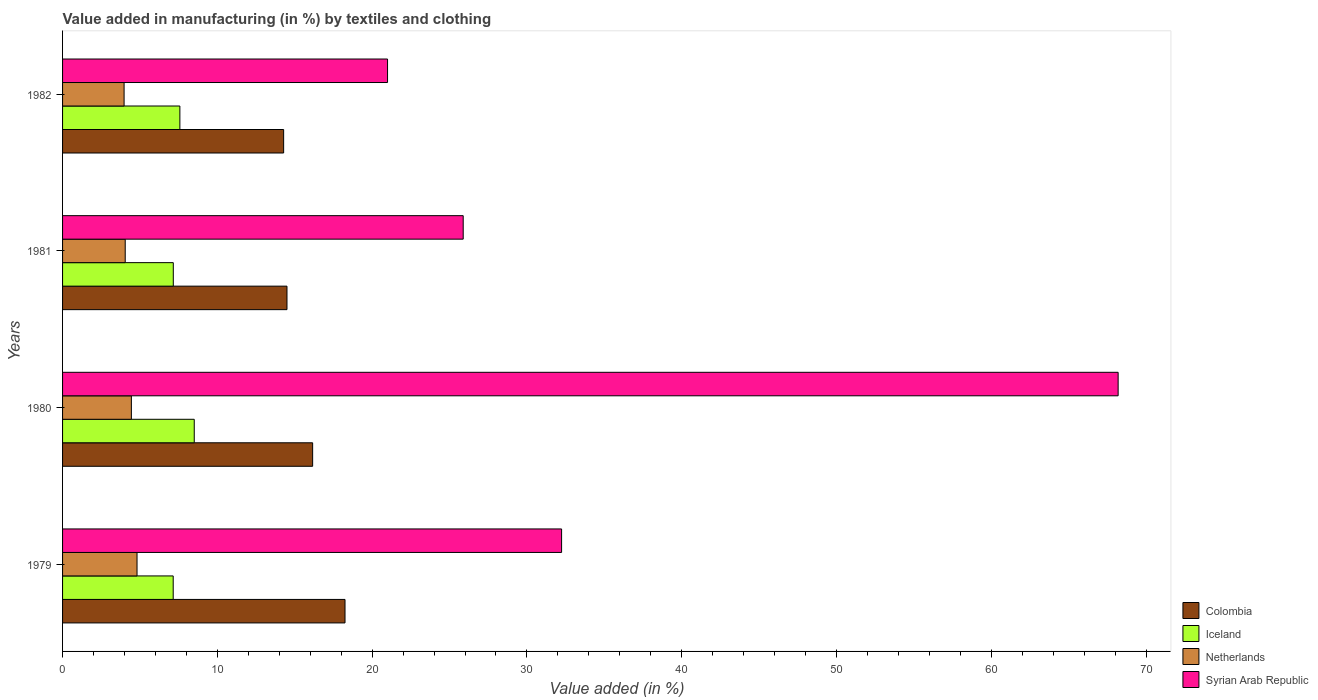How many groups of bars are there?
Give a very brief answer. 4. Are the number of bars per tick equal to the number of legend labels?
Keep it short and to the point. Yes. How many bars are there on the 3rd tick from the top?
Give a very brief answer. 4. What is the label of the 3rd group of bars from the top?
Give a very brief answer. 1980. In how many cases, is the number of bars for a given year not equal to the number of legend labels?
Offer a very short reply. 0. What is the percentage of value added in manufacturing by textiles and clothing in Netherlands in 1979?
Ensure brevity in your answer.  4.81. Across all years, what is the maximum percentage of value added in manufacturing by textiles and clothing in Iceland?
Provide a short and direct response. 8.51. Across all years, what is the minimum percentage of value added in manufacturing by textiles and clothing in Iceland?
Keep it short and to the point. 7.15. In which year was the percentage of value added in manufacturing by textiles and clothing in Netherlands maximum?
Your response must be concise. 1979. In which year was the percentage of value added in manufacturing by textiles and clothing in Netherlands minimum?
Provide a succinct answer. 1982. What is the total percentage of value added in manufacturing by textiles and clothing in Syrian Arab Republic in the graph?
Your response must be concise. 147.32. What is the difference between the percentage of value added in manufacturing by textiles and clothing in Colombia in 1979 and that in 1980?
Your answer should be compact. 2.09. What is the difference between the percentage of value added in manufacturing by textiles and clothing in Colombia in 1981 and the percentage of value added in manufacturing by textiles and clothing in Syrian Arab Republic in 1980?
Keep it short and to the point. -53.7. What is the average percentage of value added in manufacturing by textiles and clothing in Iceland per year?
Provide a short and direct response. 7.6. In the year 1981, what is the difference between the percentage of value added in manufacturing by textiles and clothing in Netherlands and percentage of value added in manufacturing by textiles and clothing in Syrian Arab Republic?
Provide a succinct answer. -21.84. In how many years, is the percentage of value added in manufacturing by textiles and clothing in Netherlands greater than 24 %?
Offer a very short reply. 0. What is the ratio of the percentage of value added in manufacturing by textiles and clothing in Netherlands in 1979 to that in 1982?
Offer a very short reply. 1.21. Is the percentage of value added in manufacturing by textiles and clothing in Netherlands in 1979 less than that in 1982?
Keep it short and to the point. No. Is the difference between the percentage of value added in manufacturing by textiles and clothing in Netherlands in 1979 and 1982 greater than the difference between the percentage of value added in manufacturing by textiles and clothing in Syrian Arab Republic in 1979 and 1982?
Your answer should be very brief. No. What is the difference between the highest and the second highest percentage of value added in manufacturing by textiles and clothing in Syrian Arab Republic?
Your answer should be very brief. 35.96. What is the difference between the highest and the lowest percentage of value added in manufacturing by textiles and clothing in Netherlands?
Ensure brevity in your answer.  0.84. What does the 3rd bar from the bottom in 1979 represents?
Offer a terse response. Netherlands. Is it the case that in every year, the sum of the percentage of value added in manufacturing by textiles and clothing in Colombia and percentage of value added in manufacturing by textiles and clothing in Netherlands is greater than the percentage of value added in manufacturing by textiles and clothing in Iceland?
Give a very brief answer. Yes. How many bars are there?
Your response must be concise. 16. How many years are there in the graph?
Provide a succinct answer. 4. What is the difference between two consecutive major ticks on the X-axis?
Provide a short and direct response. 10. Does the graph contain any zero values?
Give a very brief answer. No. How many legend labels are there?
Keep it short and to the point. 4. How are the legend labels stacked?
Give a very brief answer. Vertical. What is the title of the graph?
Offer a very short reply. Value added in manufacturing (in %) by textiles and clothing. Does "Morocco" appear as one of the legend labels in the graph?
Your response must be concise. No. What is the label or title of the X-axis?
Provide a succinct answer. Value added (in %). What is the Value added (in %) in Colombia in 1979?
Make the answer very short. 18.25. What is the Value added (in %) in Iceland in 1979?
Keep it short and to the point. 7.15. What is the Value added (in %) in Netherlands in 1979?
Provide a short and direct response. 4.81. What is the Value added (in %) of Syrian Arab Republic in 1979?
Keep it short and to the point. 32.24. What is the Value added (in %) in Colombia in 1980?
Your response must be concise. 16.16. What is the Value added (in %) in Iceland in 1980?
Keep it short and to the point. 8.51. What is the Value added (in %) in Netherlands in 1980?
Give a very brief answer. 4.45. What is the Value added (in %) of Syrian Arab Republic in 1980?
Your answer should be compact. 68.2. What is the Value added (in %) of Colombia in 1981?
Your answer should be compact. 14.5. What is the Value added (in %) in Iceland in 1981?
Provide a succinct answer. 7.15. What is the Value added (in %) in Netherlands in 1981?
Provide a succinct answer. 4.05. What is the Value added (in %) of Syrian Arab Republic in 1981?
Ensure brevity in your answer.  25.88. What is the Value added (in %) in Colombia in 1982?
Offer a terse response. 14.28. What is the Value added (in %) in Iceland in 1982?
Ensure brevity in your answer.  7.58. What is the Value added (in %) of Netherlands in 1982?
Ensure brevity in your answer.  3.97. What is the Value added (in %) of Syrian Arab Republic in 1982?
Give a very brief answer. 21. Across all years, what is the maximum Value added (in %) of Colombia?
Make the answer very short. 18.25. Across all years, what is the maximum Value added (in %) in Iceland?
Make the answer very short. 8.51. Across all years, what is the maximum Value added (in %) of Netherlands?
Your answer should be compact. 4.81. Across all years, what is the maximum Value added (in %) of Syrian Arab Republic?
Provide a succinct answer. 68.2. Across all years, what is the minimum Value added (in %) of Colombia?
Ensure brevity in your answer.  14.28. Across all years, what is the minimum Value added (in %) in Iceland?
Offer a terse response. 7.15. Across all years, what is the minimum Value added (in %) in Netherlands?
Ensure brevity in your answer.  3.97. Across all years, what is the minimum Value added (in %) of Syrian Arab Republic?
Ensure brevity in your answer.  21. What is the total Value added (in %) of Colombia in the graph?
Offer a very short reply. 63.19. What is the total Value added (in %) of Iceland in the graph?
Offer a very short reply. 30.39. What is the total Value added (in %) in Netherlands in the graph?
Keep it short and to the point. 17.28. What is the total Value added (in %) of Syrian Arab Republic in the graph?
Your answer should be very brief. 147.32. What is the difference between the Value added (in %) of Colombia in 1979 and that in 1980?
Keep it short and to the point. 2.09. What is the difference between the Value added (in %) in Iceland in 1979 and that in 1980?
Your answer should be compact. -1.36. What is the difference between the Value added (in %) of Netherlands in 1979 and that in 1980?
Your response must be concise. 0.37. What is the difference between the Value added (in %) in Syrian Arab Republic in 1979 and that in 1980?
Provide a short and direct response. -35.96. What is the difference between the Value added (in %) in Colombia in 1979 and that in 1981?
Offer a terse response. 3.75. What is the difference between the Value added (in %) in Iceland in 1979 and that in 1981?
Keep it short and to the point. -0.01. What is the difference between the Value added (in %) in Netherlands in 1979 and that in 1981?
Offer a terse response. 0.76. What is the difference between the Value added (in %) of Syrian Arab Republic in 1979 and that in 1981?
Your answer should be compact. 6.36. What is the difference between the Value added (in %) of Colombia in 1979 and that in 1982?
Offer a terse response. 3.97. What is the difference between the Value added (in %) in Iceland in 1979 and that in 1982?
Offer a terse response. -0.43. What is the difference between the Value added (in %) in Netherlands in 1979 and that in 1982?
Offer a terse response. 0.84. What is the difference between the Value added (in %) in Syrian Arab Republic in 1979 and that in 1982?
Make the answer very short. 11.24. What is the difference between the Value added (in %) of Colombia in 1980 and that in 1981?
Your response must be concise. 1.66. What is the difference between the Value added (in %) of Iceland in 1980 and that in 1981?
Give a very brief answer. 1.35. What is the difference between the Value added (in %) of Netherlands in 1980 and that in 1981?
Offer a very short reply. 0.4. What is the difference between the Value added (in %) of Syrian Arab Republic in 1980 and that in 1981?
Provide a short and direct response. 42.31. What is the difference between the Value added (in %) in Colombia in 1980 and that in 1982?
Your response must be concise. 1.87. What is the difference between the Value added (in %) in Netherlands in 1980 and that in 1982?
Make the answer very short. 0.47. What is the difference between the Value added (in %) in Syrian Arab Republic in 1980 and that in 1982?
Offer a very short reply. 47.2. What is the difference between the Value added (in %) of Colombia in 1981 and that in 1982?
Your answer should be very brief. 0.22. What is the difference between the Value added (in %) in Iceland in 1981 and that in 1982?
Your answer should be very brief. -0.42. What is the difference between the Value added (in %) of Netherlands in 1981 and that in 1982?
Your answer should be compact. 0.07. What is the difference between the Value added (in %) of Syrian Arab Republic in 1981 and that in 1982?
Provide a short and direct response. 4.89. What is the difference between the Value added (in %) of Colombia in 1979 and the Value added (in %) of Iceland in 1980?
Keep it short and to the point. 9.74. What is the difference between the Value added (in %) in Colombia in 1979 and the Value added (in %) in Netherlands in 1980?
Your response must be concise. 13.8. What is the difference between the Value added (in %) of Colombia in 1979 and the Value added (in %) of Syrian Arab Republic in 1980?
Ensure brevity in your answer.  -49.95. What is the difference between the Value added (in %) of Iceland in 1979 and the Value added (in %) of Netherlands in 1980?
Your response must be concise. 2.7. What is the difference between the Value added (in %) in Iceland in 1979 and the Value added (in %) in Syrian Arab Republic in 1980?
Offer a very short reply. -61.05. What is the difference between the Value added (in %) of Netherlands in 1979 and the Value added (in %) of Syrian Arab Republic in 1980?
Offer a terse response. -63.39. What is the difference between the Value added (in %) in Colombia in 1979 and the Value added (in %) in Iceland in 1981?
Your response must be concise. 11.09. What is the difference between the Value added (in %) in Colombia in 1979 and the Value added (in %) in Netherlands in 1981?
Offer a terse response. 14.2. What is the difference between the Value added (in %) of Colombia in 1979 and the Value added (in %) of Syrian Arab Republic in 1981?
Offer a terse response. -7.64. What is the difference between the Value added (in %) in Iceland in 1979 and the Value added (in %) in Netherlands in 1981?
Your answer should be very brief. 3.1. What is the difference between the Value added (in %) of Iceland in 1979 and the Value added (in %) of Syrian Arab Republic in 1981?
Offer a very short reply. -18.74. What is the difference between the Value added (in %) of Netherlands in 1979 and the Value added (in %) of Syrian Arab Republic in 1981?
Provide a short and direct response. -21.07. What is the difference between the Value added (in %) in Colombia in 1979 and the Value added (in %) in Iceland in 1982?
Your answer should be very brief. 10.67. What is the difference between the Value added (in %) in Colombia in 1979 and the Value added (in %) in Netherlands in 1982?
Make the answer very short. 14.27. What is the difference between the Value added (in %) in Colombia in 1979 and the Value added (in %) in Syrian Arab Republic in 1982?
Your response must be concise. -2.75. What is the difference between the Value added (in %) in Iceland in 1979 and the Value added (in %) in Netherlands in 1982?
Provide a succinct answer. 3.17. What is the difference between the Value added (in %) of Iceland in 1979 and the Value added (in %) of Syrian Arab Republic in 1982?
Your answer should be very brief. -13.85. What is the difference between the Value added (in %) in Netherlands in 1979 and the Value added (in %) in Syrian Arab Republic in 1982?
Offer a very short reply. -16.19. What is the difference between the Value added (in %) of Colombia in 1980 and the Value added (in %) of Iceland in 1981?
Give a very brief answer. 9. What is the difference between the Value added (in %) of Colombia in 1980 and the Value added (in %) of Netherlands in 1981?
Offer a very short reply. 12.11. What is the difference between the Value added (in %) in Colombia in 1980 and the Value added (in %) in Syrian Arab Republic in 1981?
Ensure brevity in your answer.  -9.73. What is the difference between the Value added (in %) of Iceland in 1980 and the Value added (in %) of Netherlands in 1981?
Provide a succinct answer. 4.46. What is the difference between the Value added (in %) of Iceland in 1980 and the Value added (in %) of Syrian Arab Republic in 1981?
Make the answer very short. -17.38. What is the difference between the Value added (in %) of Netherlands in 1980 and the Value added (in %) of Syrian Arab Republic in 1981?
Offer a very short reply. -21.44. What is the difference between the Value added (in %) of Colombia in 1980 and the Value added (in %) of Iceland in 1982?
Offer a terse response. 8.58. What is the difference between the Value added (in %) in Colombia in 1980 and the Value added (in %) in Netherlands in 1982?
Keep it short and to the point. 12.18. What is the difference between the Value added (in %) of Colombia in 1980 and the Value added (in %) of Syrian Arab Republic in 1982?
Ensure brevity in your answer.  -4.84. What is the difference between the Value added (in %) of Iceland in 1980 and the Value added (in %) of Netherlands in 1982?
Make the answer very short. 4.53. What is the difference between the Value added (in %) of Iceland in 1980 and the Value added (in %) of Syrian Arab Republic in 1982?
Keep it short and to the point. -12.49. What is the difference between the Value added (in %) of Netherlands in 1980 and the Value added (in %) of Syrian Arab Republic in 1982?
Provide a short and direct response. -16.55. What is the difference between the Value added (in %) in Colombia in 1981 and the Value added (in %) in Iceland in 1982?
Ensure brevity in your answer.  6.92. What is the difference between the Value added (in %) in Colombia in 1981 and the Value added (in %) in Netherlands in 1982?
Offer a terse response. 10.52. What is the difference between the Value added (in %) in Colombia in 1981 and the Value added (in %) in Syrian Arab Republic in 1982?
Your answer should be compact. -6.5. What is the difference between the Value added (in %) in Iceland in 1981 and the Value added (in %) in Netherlands in 1982?
Offer a very short reply. 3.18. What is the difference between the Value added (in %) in Iceland in 1981 and the Value added (in %) in Syrian Arab Republic in 1982?
Give a very brief answer. -13.84. What is the difference between the Value added (in %) of Netherlands in 1981 and the Value added (in %) of Syrian Arab Republic in 1982?
Keep it short and to the point. -16.95. What is the average Value added (in %) in Colombia per year?
Offer a terse response. 15.8. What is the average Value added (in %) in Iceland per year?
Your answer should be compact. 7.6. What is the average Value added (in %) in Netherlands per year?
Your answer should be very brief. 4.32. What is the average Value added (in %) in Syrian Arab Republic per year?
Provide a succinct answer. 36.83. In the year 1979, what is the difference between the Value added (in %) in Colombia and Value added (in %) in Iceland?
Provide a short and direct response. 11.1. In the year 1979, what is the difference between the Value added (in %) of Colombia and Value added (in %) of Netherlands?
Your answer should be compact. 13.44. In the year 1979, what is the difference between the Value added (in %) in Colombia and Value added (in %) in Syrian Arab Republic?
Your answer should be very brief. -13.99. In the year 1979, what is the difference between the Value added (in %) in Iceland and Value added (in %) in Netherlands?
Provide a succinct answer. 2.34. In the year 1979, what is the difference between the Value added (in %) in Iceland and Value added (in %) in Syrian Arab Republic?
Provide a short and direct response. -25.09. In the year 1979, what is the difference between the Value added (in %) in Netherlands and Value added (in %) in Syrian Arab Republic?
Your response must be concise. -27.43. In the year 1980, what is the difference between the Value added (in %) of Colombia and Value added (in %) of Iceland?
Your response must be concise. 7.65. In the year 1980, what is the difference between the Value added (in %) of Colombia and Value added (in %) of Netherlands?
Offer a terse response. 11.71. In the year 1980, what is the difference between the Value added (in %) of Colombia and Value added (in %) of Syrian Arab Republic?
Provide a short and direct response. -52.04. In the year 1980, what is the difference between the Value added (in %) of Iceland and Value added (in %) of Netherlands?
Keep it short and to the point. 4.06. In the year 1980, what is the difference between the Value added (in %) in Iceland and Value added (in %) in Syrian Arab Republic?
Keep it short and to the point. -59.69. In the year 1980, what is the difference between the Value added (in %) in Netherlands and Value added (in %) in Syrian Arab Republic?
Give a very brief answer. -63.75. In the year 1981, what is the difference between the Value added (in %) in Colombia and Value added (in %) in Iceland?
Provide a succinct answer. 7.35. In the year 1981, what is the difference between the Value added (in %) in Colombia and Value added (in %) in Netherlands?
Give a very brief answer. 10.45. In the year 1981, what is the difference between the Value added (in %) in Colombia and Value added (in %) in Syrian Arab Republic?
Offer a terse response. -11.38. In the year 1981, what is the difference between the Value added (in %) of Iceland and Value added (in %) of Netherlands?
Ensure brevity in your answer.  3.11. In the year 1981, what is the difference between the Value added (in %) of Iceland and Value added (in %) of Syrian Arab Republic?
Your answer should be very brief. -18.73. In the year 1981, what is the difference between the Value added (in %) in Netherlands and Value added (in %) in Syrian Arab Republic?
Your answer should be very brief. -21.84. In the year 1982, what is the difference between the Value added (in %) in Colombia and Value added (in %) in Iceland?
Offer a terse response. 6.7. In the year 1982, what is the difference between the Value added (in %) of Colombia and Value added (in %) of Netherlands?
Give a very brief answer. 10.31. In the year 1982, what is the difference between the Value added (in %) of Colombia and Value added (in %) of Syrian Arab Republic?
Offer a terse response. -6.71. In the year 1982, what is the difference between the Value added (in %) of Iceland and Value added (in %) of Netherlands?
Your answer should be very brief. 3.6. In the year 1982, what is the difference between the Value added (in %) in Iceland and Value added (in %) in Syrian Arab Republic?
Keep it short and to the point. -13.42. In the year 1982, what is the difference between the Value added (in %) of Netherlands and Value added (in %) of Syrian Arab Republic?
Provide a short and direct response. -17.02. What is the ratio of the Value added (in %) in Colombia in 1979 to that in 1980?
Offer a terse response. 1.13. What is the ratio of the Value added (in %) in Iceland in 1979 to that in 1980?
Your answer should be very brief. 0.84. What is the ratio of the Value added (in %) in Netherlands in 1979 to that in 1980?
Provide a succinct answer. 1.08. What is the ratio of the Value added (in %) in Syrian Arab Republic in 1979 to that in 1980?
Give a very brief answer. 0.47. What is the ratio of the Value added (in %) in Colombia in 1979 to that in 1981?
Your answer should be very brief. 1.26. What is the ratio of the Value added (in %) in Iceland in 1979 to that in 1981?
Keep it short and to the point. 1. What is the ratio of the Value added (in %) of Netherlands in 1979 to that in 1981?
Your answer should be compact. 1.19. What is the ratio of the Value added (in %) in Syrian Arab Republic in 1979 to that in 1981?
Offer a very short reply. 1.25. What is the ratio of the Value added (in %) of Colombia in 1979 to that in 1982?
Your response must be concise. 1.28. What is the ratio of the Value added (in %) of Iceland in 1979 to that in 1982?
Provide a succinct answer. 0.94. What is the ratio of the Value added (in %) of Netherlands in 1979 to that in 1982?
Your answer should be compact. 1.21. What is the ratio of the Value added (in %) of Syrian Arab Republic in 1979 to that in 1982?
Offer a very short reply. 1.54. What is the ratio of the Value added (in %) of Colombia in 1980 to that in 1981?
Keep it short and to the point. 1.11. What is the ratio of the Value added (in %) of Iceland in 1980 to that in 1981?
Make the answer very short. 1.19. What is the ratio of the Value added (in %) in Netherlands in 1980 to that in 1981?
Your answer should be very brief. 1.1. What is the ratio of the Value added (in %) of Syrian Arab Republic in 1980 to that in 1981?
Provide a succinct answer. 2.63. What is the ratio of the Value added (in %) of Colombia in 1980 to that in 1982?
Provide a succinct answer. 1.13. What is the ratio of the Value added (in %) in Iceland in 1980 to that in 1982?
Your response must be concise. 1.12. What is the ratio of the Value added (in %) of Netherlands in 1980 to that in 1982?
Give a very brief answer. 1.12. What is the ratio of the Value added (in %) of Syrian Arab Republic in 1980 to that in 1982?
Give a very brief answer. 3.25. What is the ratio of the Value added (in %) of Colombia in 1981 to that in 1982?
Offer a very short reply. 1.02. What is the ratio of the Value added (in %) of Iceland in 1981 to that in 1982?
Keep it short and to the point. 0.94. What is the ratio of the Value added (in %) of Netherlands in 1981 to that in 1982?
Ensure brevity in your answer.  1.02. What is the ratio of the Value added (in %) of Syrian Arab Republic in 1981 to that in 1982?
Your answer should be compact. 1.23. What is the difference between the highest and the second highest Value added (in %) in Colombia?
Provide a succinct answer. 2.09. What is the difference between the highest and the second highest Value added (in %) in Netherlands?
Your answer should be very brief. 0.37. What is the difference between the highest and the second highest Value added (in %) in Syrian Arab Republic?
Offer a terse response. 35.96. What is the difference between the highest and the lowest Value added (in %) of Colombia?
Provide a short and direct response. 3.97. What is the difference between the highest and the lowest Value added (in %) in Iceland?
Ensure brevity in your answer.  1.36. What is the difference between the highest and the lowest Value added (in %) in Netherlands?
Give a very brief answer. 0.84. What is the difference between the highest and the lowest Value added (in %) of Syrian Arab Republic?
Make the answer very short. 47.2. 